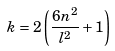<formula> <loc_0><loc_0><loc_500><loc_500>k = 2 \left ( \frac { 6 n ^ { 2 } } { l ^ { 2 } } + 1 \right )</formula> 